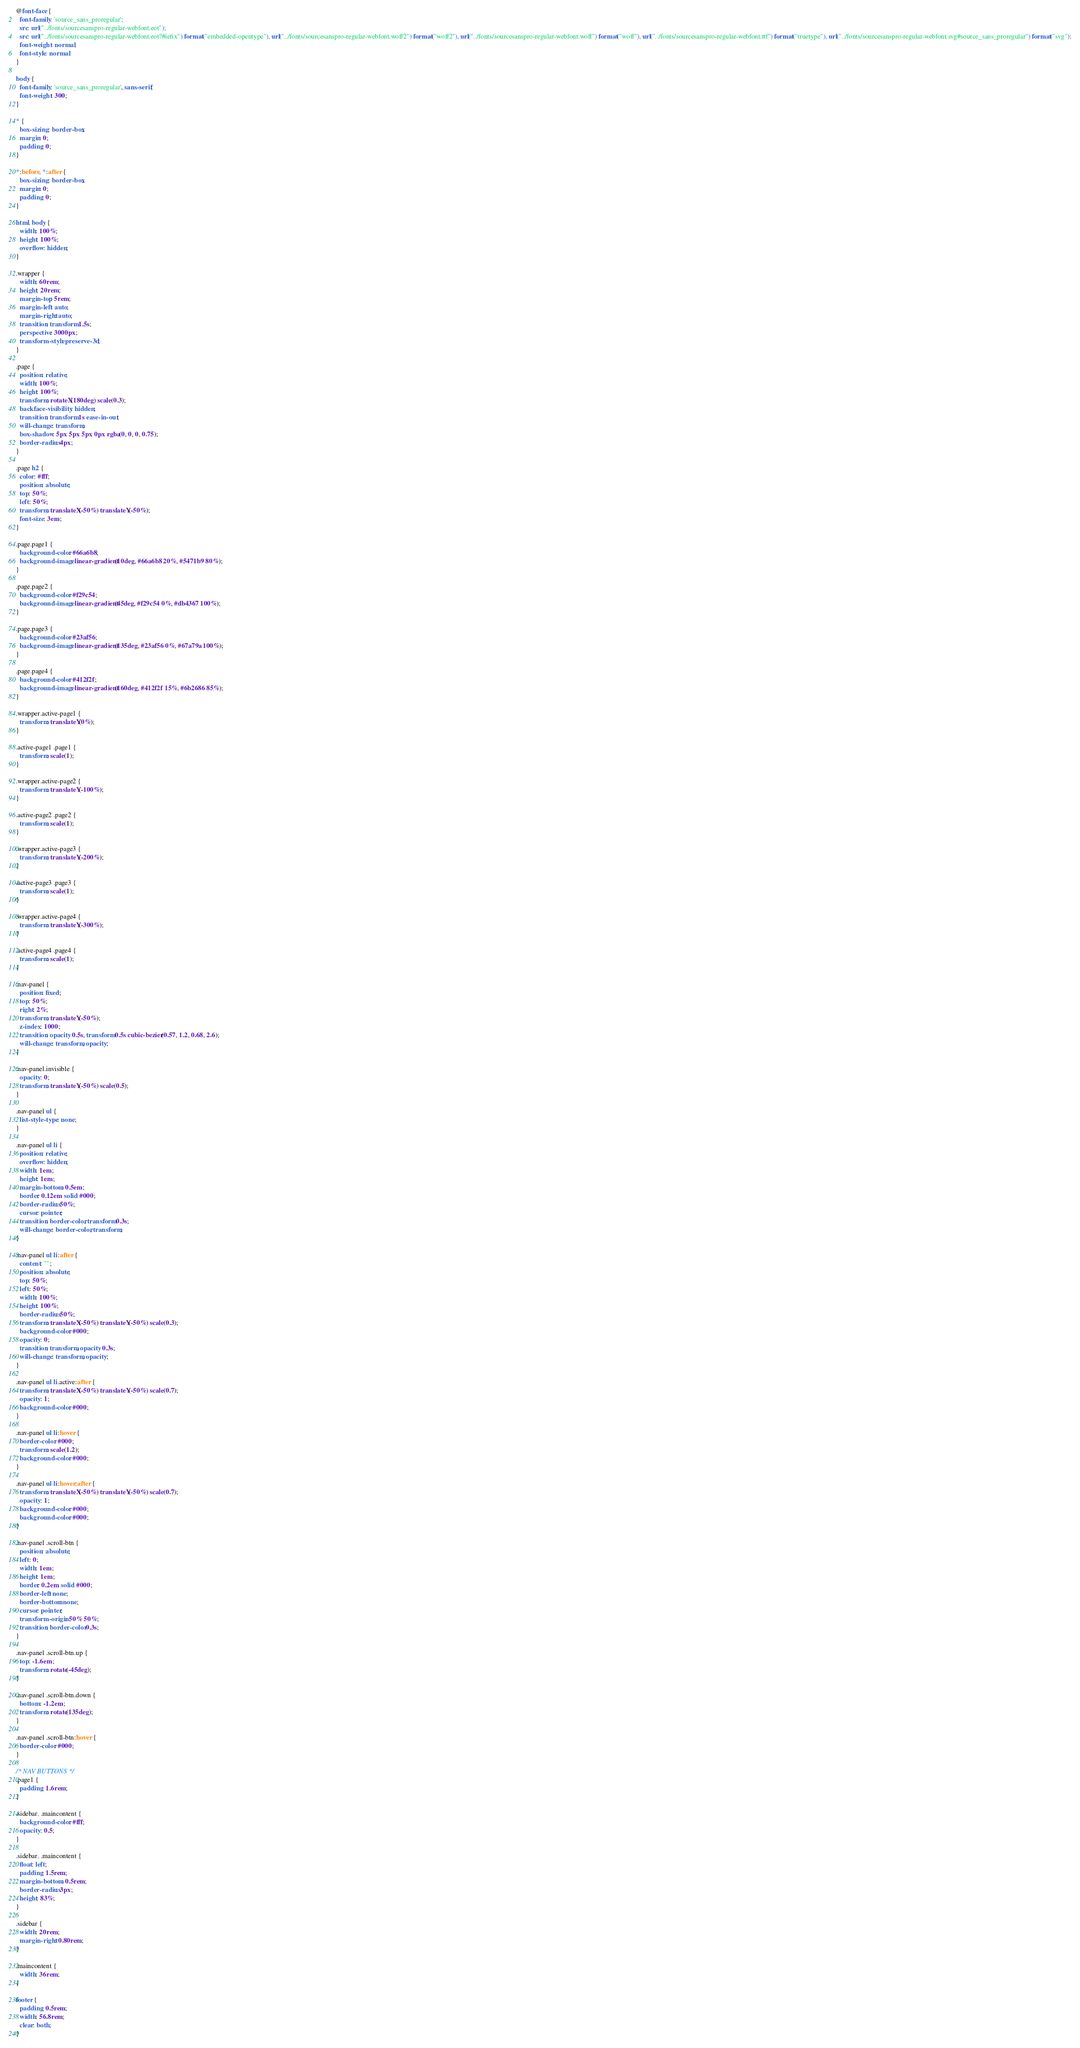<code> <loc_0><loc_0><loc_500><loc_500><_CSS_>@font-face {
  font-family: 'source_sans_proregular';
  src: url("../fonts/sourcesanspro-regular-webfont.eot");
  src: url("../fonts/sourcesanspro-regular-webfont.eot?#iefix") format("embedded-opentype"), url("../fonts/sourcesanspro-regular-webfont.woff2") format("woff2"), url("../fonts/sourcesanspro-regular-webfont.woff") format("woff"), url("../fonts/sourcesanspro-regular-webfont.ttf") format("truetype"), url("../fonts/sourcesanspro-regular-webfont.svg#source_sans_proregular") format("svg");
  font-weight: normal;
  font-style: normal;
}

body {
  font-family: 'source_sans_proregular', sans-serif;
  font-weight: 300;
}

* {
  box-sizing: border-box;
  margin: 0;
  padding: 0;
}

*:before, *:after {
  box-sizing: border-box;
  margin: 0;
  padding: 0;
}

html, body {
  width: 100%;
  height: 100%;
  overflow: hidden;
}

.wrapper {
  width: 60rem;
  height: 20rem;
  margin-top: 5rem;
  margin-left: auto;
  margin-right: auto;
  transition: transform 1.5s;
  perspective: 3000px;
  transform-style: preserve-3d;
}

.page {
  position: relative;
  width: 100%;
  height: 100%;
  transform: rotateX(180deg) scale(0.3);
  backface-visibility: hidden;
  transition: transform 1s ease-in-out;
  will-change: transform;
  box-shadow: 5px 5px 5px 0px rgba(0, 0, 0, 0.75);
  border-radius: 4px;
}

.page h2 {
  color: #fff;
  position: absolute;
  top: 50%;
  left: 50%;
  transform: translateX(-50%) translateY(-50%);
  font-size: 3em;
}

.page.page1 {
  background-color: #66a6b8;
  background-image: linear-gradient(10deg, #66a6b8 20%, #5471b9 80%);
}

.page.page2 {
  background-color: #f29c54;
  background-image: linear-gradient(45deg, #f29c54 0%, #db4367 100%);
}

.page.page3 {
  background-color: #23af56;
  background-image: linear-gradient(135deg, #23af56 0%, #67a79a 100%);
}

.page.page4 {
  background-color: #412f2f;
  background-image: linear-gradient(160deg, #412f2f 15%, #6b2686 85%);
}

.wrapper.active-page1 {
  transform: translateY(0%);
}

.active-page1 .page1 {
  transform: scale(1);
}

.wrapper.active-page2 {
  transform: translateY(-100%);
}

.active-page2 .page2 {
  transform: scale(1);
}

.wrapper.active-page3 {
  transform: translateY(-200%);
}

.active-page3 .page3 {
  transform: scale(1);
}

.wrapper.active-page4 {
  transform: translateY(-300%);
}

.active-page4 .page4 {
  transform: scale(1);
}

.nav-panel {
  position: fixed;
  top: 50%;
  right: 2%;
  transform: translateY(-50%);
  z-index: 1000;
  transition: opacity 0.5s, transform 0.5s cubic-bezier(0.57, 1.2, 0.68, 2.6);
  will-change: transform, opacity;
}

.nav-panel.invisible {
  opacity: 0;
  transform: translateY(-50%) scale(0.5);
}

.nav-panel ul {
  list-style-type: none;
}

.nav-panel ul li {
  position: relative;
  overflow: hidden;
  width: 1em;
  height: 1em;
  margin-bottom: 0.5em;
  border: 0.12em solid #000;
  border-radius: 50%;
  cursor: pointer;
  transition: border-color, transform 0.3s;
  will-change: border-color, transform;
}

.nav-panel ul li:after {
  content: "";
  position: absolute;
  top: 50%;
  left: 50%;
  width: 100%;
  height: 100%;
  border-radius: 50%;
  transform: translateX(-50%) translateY(-50%) scale(0.3);
  background-color: #000;
  opacity: 0;
  transition: transform, opacity 0.3s;
  will-change: transform, opacity;
}

.nav-panel ul li.active:after {
  transform: translateX(-50%) translateY(-50%) scale(0.7);
  opacity: 1;
  background-color: #000;
}

.nav-panel ul li:hover {
  border-color: #000;
  transform: scale(1.2);
  background-color: #000;
}

.nav-panel ul li:hover:after {
  transform: translateX(-50%) translateY(-50%) scale(0.7);
  opacity: 1;
  background-color: #000;
  background-color: #000;
}

.nav-panel .scroll-btn {
  position: absolute;
  left: 0;
  width: 1em;
  height: 1em;
  border: 0.2em solid #000;
  border-left: none;
  border-bottom: none;
  cursor: pointer;
  transform-origin: 50% 50%;
  transition: border-color 0.3s;
}

.nav-panel .scroll-btn.up {
  top: -1.6em;
  transform: rotate(-45deg);
}

.nav-panel .scroll-btn.down {
  bottom: -1.2em;
  transform: rotate(135deg);
}

.nav-panel .scroll-btn:hover {
  border-color: #000;
}

/* NAV BUTTONS */
.page1 {
  padding: 1.6rem;
}

.sidebar, .maincontent {
  background-color: #fff;
  opacity: 0.5;
}

.sidebar, .maincontent {
  float: left;
  padding: 1.5rem;
  margin-bottom: 0.5rem;
  border-radius: 3px;
  height: 83%;
}

.sidebar {
  width: 20rem;
  margin-right: 0.80rem;
}

.maincontent {
  width: 36rem;
}

footer {
  padding: 0.5rem;
  width: 56.8rem;
  clear: both;
}
</code> 